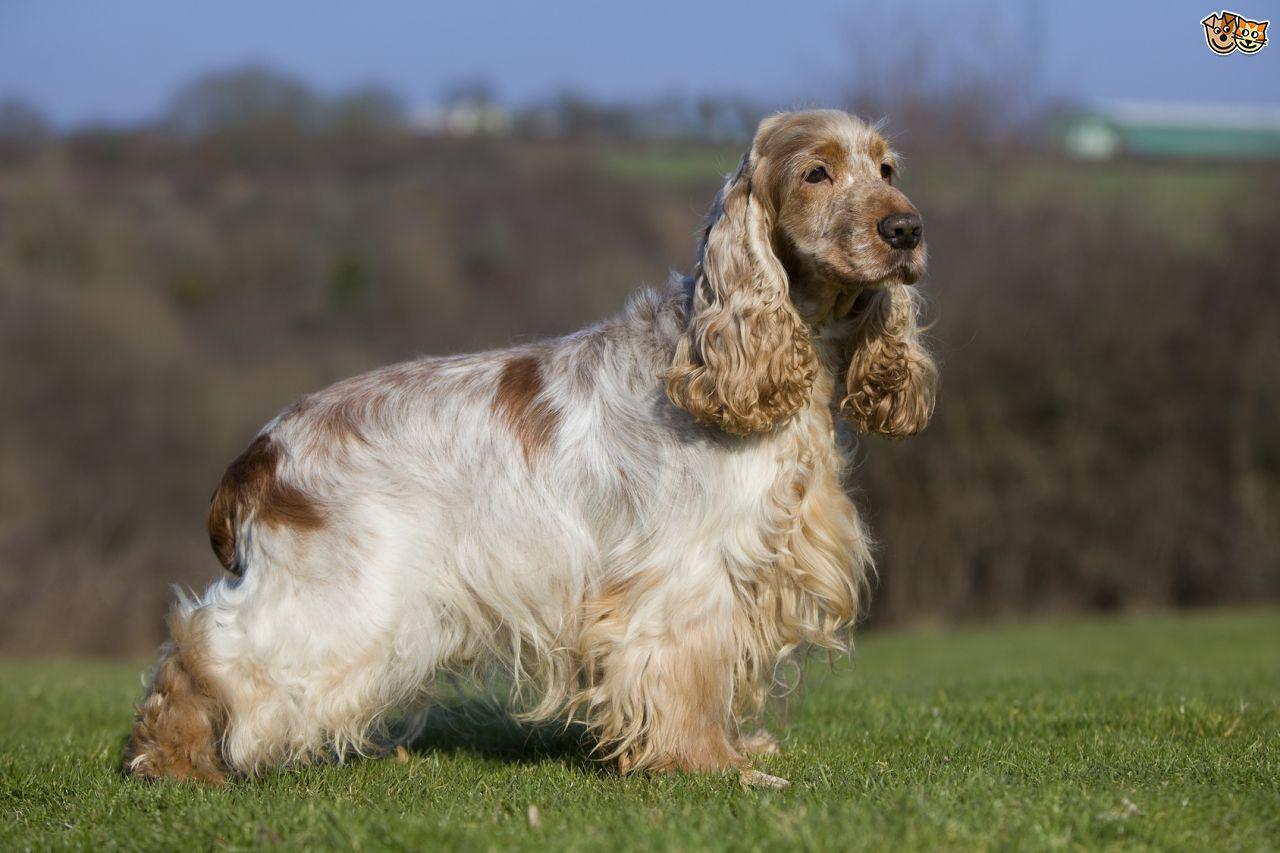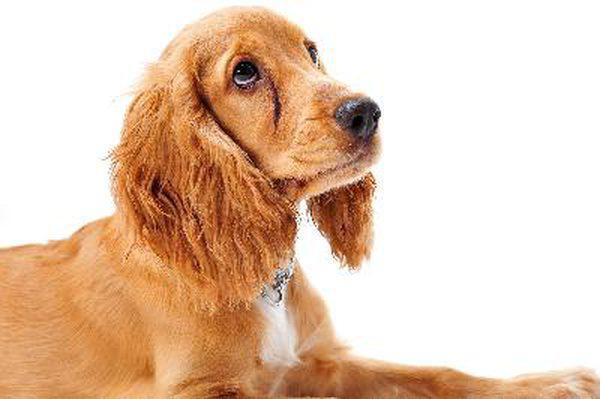The first image is the image on the left, the second image is the image on the right. Assess this claim about the two images: "There are two dogs". Correct or not? Answer yes or no. Yes. 